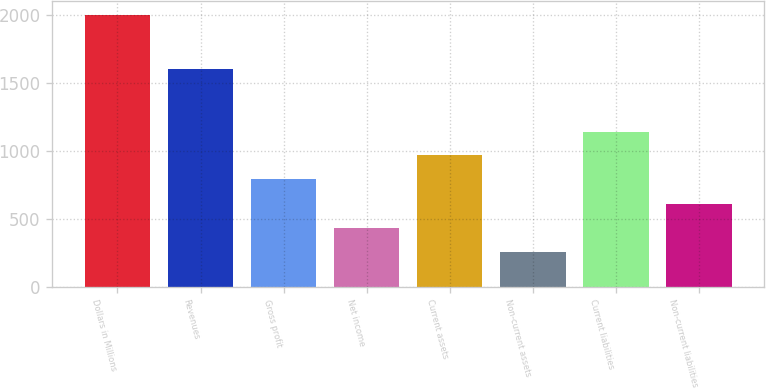Convert chart to OTSL. <chart><loc_0><loc_0><loc_500><loc_500><bar_chart><fcel>Dollars in Millions<fcel>Revenues<fcel>Gross profit<fcel>Net income<fcel>Current assets<fcel>Non-current assets<fcel>Current liabilities<fcel>Non-current liabilities<nl><fcel>2003<fcel>1605<fcel>794<fcel>433.4<fcel>968.4<fcel>259<fcel>1142.8<fcel>607.8<nl></chart> 